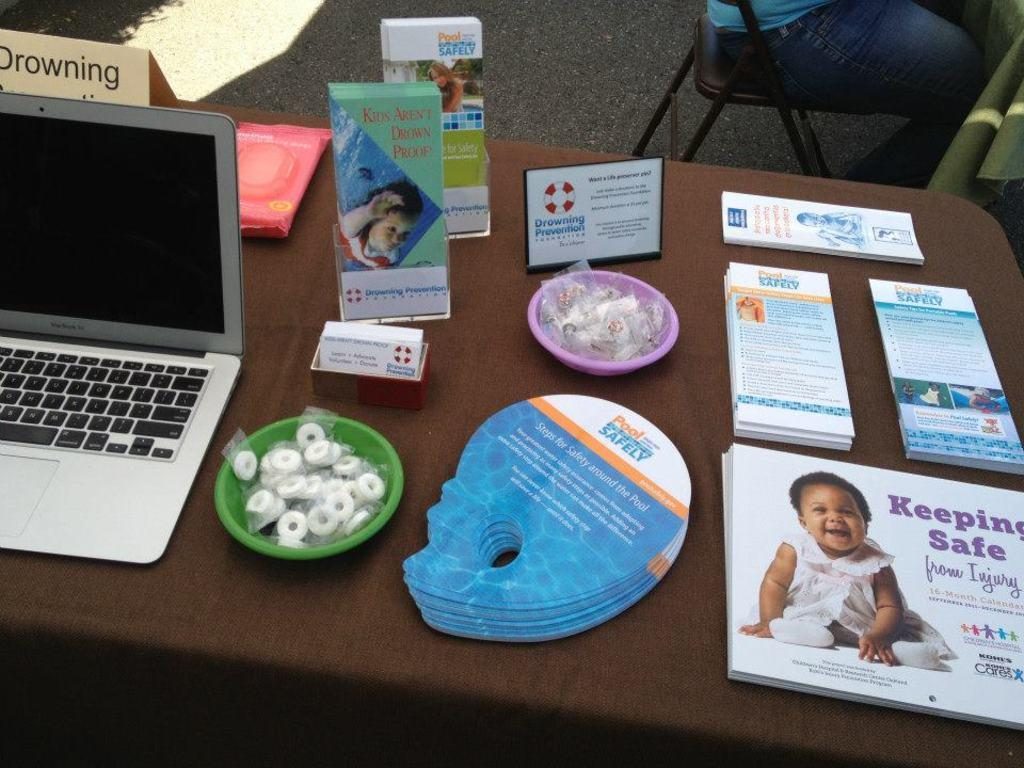<image>
Share a concise interpretation of the image provided. table with a laptop, bowl of lifesavers, brochures for pool safety and calendars for keeping safe from injury 